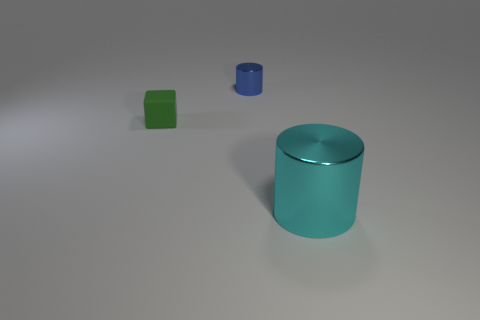Add 3 small red metal objects. How many objects exist? 6 Subtract all cylinders. How many objects are left? 1 Subtract all tiny things. Subtract all blue things. How many objects are left? 0 Add 2 cylinders. How many cylinders are left? 4 Add 2 cyan rubber cylinders. How many cyan rubber cylinders exist? 2 Subtract 0 red cylinders. How many objects are left? 3 